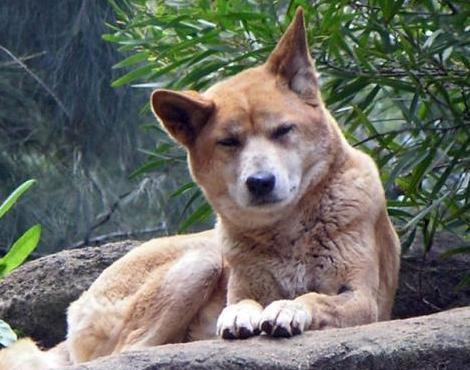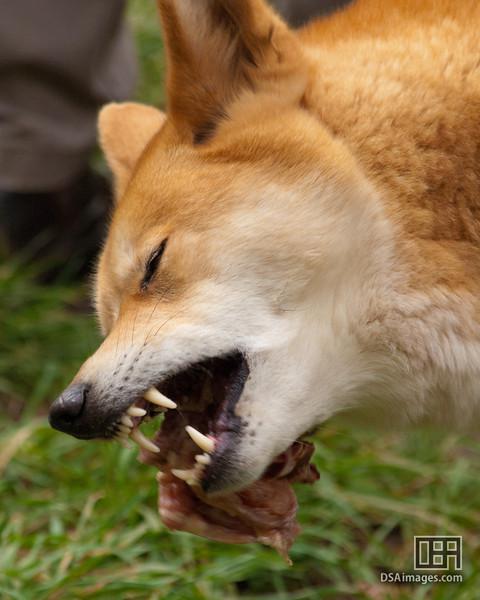The first image is the image on the left, the second image is the image on the right. Given the left and right images, does the statement "the animal in the image on the left is standing on all fours." hold true? Answer yes or no. No. The first image is the image on the left, the second image is the image on the right. Given the left and right images, does the statement "In the right image, one canine is lying on the grass." hold true? Answer yes or no. No. 